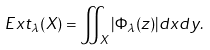Convert formula to latex. <formula><loc_0><loc_0><loc_500><loc_500>E x t _ { \lambda } ( X ) = \iint _ { X } | \Phi _ { \lambda } ( z ) | d x d y .</formula> 